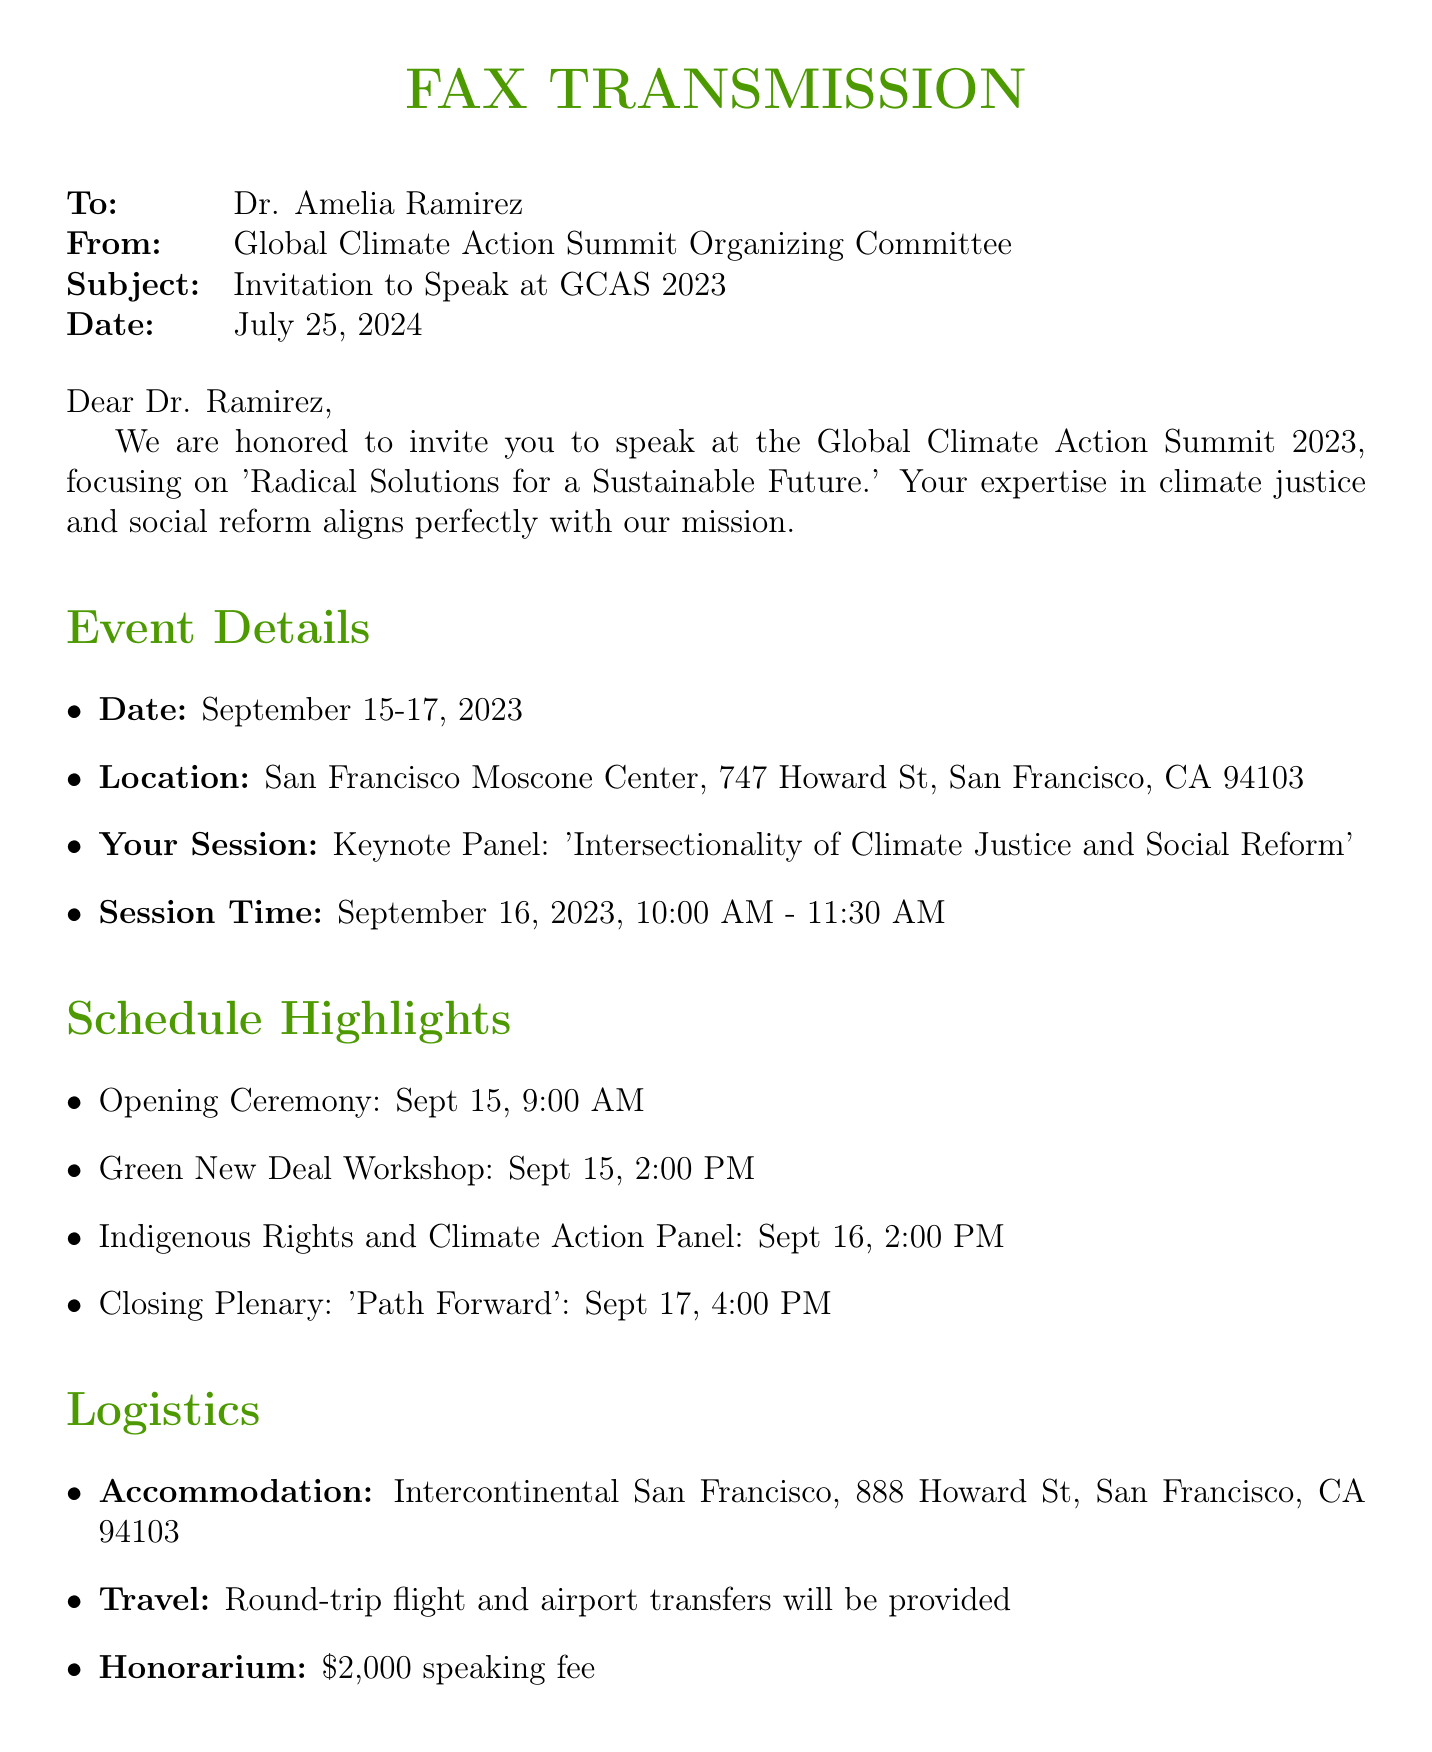What is the event date? The event will take place from September 15-17, 2023, as mentioned in the document.
Answer: September 15-17, 2023 Where is the conference located? The document provides the address for the location as San Francisco Moscone Center, 747 Howard St, San Francisco, CA 94103.
Answer: San Francisco Moscone Center, 747 Howard St, San Francisco, CA 94103 What is Dr. Ramirez's session topic? The document states the session topic as 'Intersectionality of Climate Justice and Social Reform.'
Answer: Intersectionality of Climate Justice and Social Reform What time is the keynote panel scheduled? According to the document, the keynote panel is scheduled for September 16, 2023, from 10:00 AM to 11:30 AM.
Answer: September 16, 2023, 10:00 AM - 11:30 AM What accommodation is provided? The document lists the accommodation as Intercontinental San Francisco, located at 888 Howard St, San Francisco, CA 94103.
Answer: Intercontinental San Francisco, 888 Howard St, San Francisco, CA 94103 Who should be contacted for confirmation? The document specifies that Emily Chen should be contacted for confirmation of participation.
Answer: Emily Chen What is the speaking fee mentioned? The document states that there is an honorarium of $2,000 for the speaking fee.
Answer: $2,000 What is the closing plenary topic? The document lists the closing plenary topic as 'Path Forward.'
Answer: Path Forward What time is the opening ceremony? The opening ceremony is scheduled for September 15, 2023, at 9:00 AM, according to the document.
Answer: September 15, 9:00 AM 